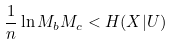<formula> <loc_0><loc_0><loc_500><loc_500>\frac { 1 } { n } \ln M _ { b } M _ { c } < H ( X | U )</formula> 